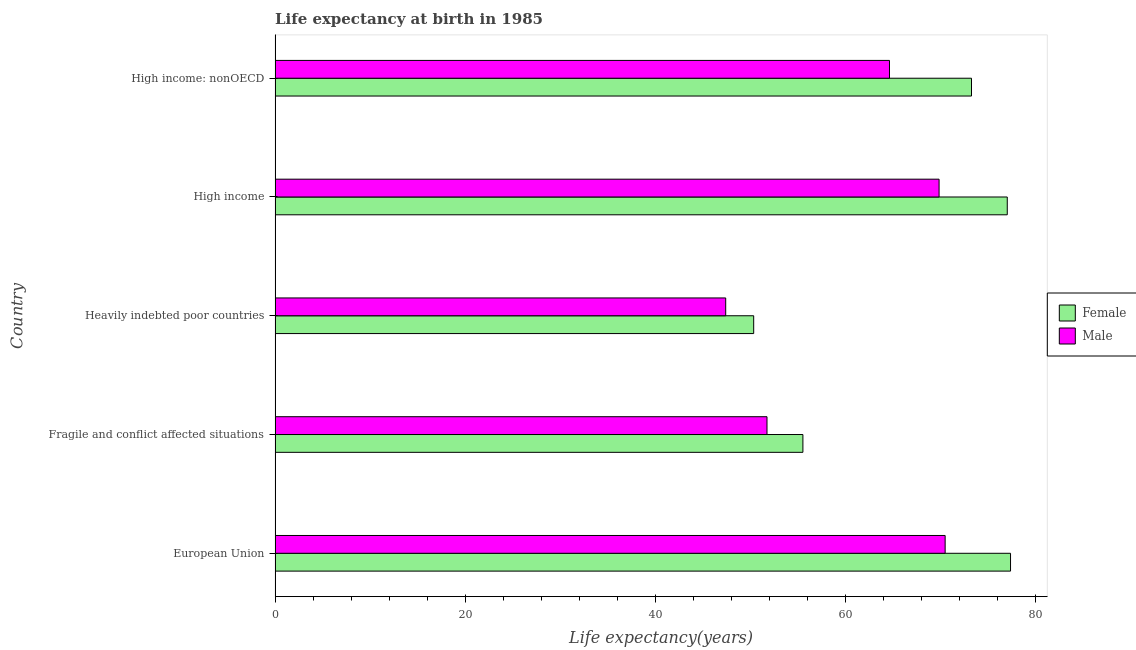How many different coloured bars are there?
Offer a terse response. 2. How many groups of bars are there?
Provide a short and direct response. 5. What is the label of the 5th group of bars from the top?
Give a very brief answer. European Union. In how many cases, is the number of bars for a given country not equal to the number of legend labels?
Make the answer very short. 0. What is the life expectancy(male) in High income?
Make the answer very short. 69.88. Across all countries, what is the maximum life expectancy(male)?
Make the answer very short. 70.52. Across all countries, what is the minimum life expectancy(female)?
Provide a succinct answer. 50.37. In which country was the life expectancy(female) maximum?
Your answer should be very brief. European Union. In which country was the life expectancy(male) minimum?
Provide a short and direct response. Heavily indebted poor countries. What is the total life expectancy(female) in the graph?
Offer a very short reply. 333.68. What is the difference between the life expectancy(female) in European Union and that in High income?
Your answer should be very brief. 0.34. What is the difference between the life expectancy(male) in Heavily indebted poor countries and the life expectancy(female) in Fragile and conflict affected situations?
Your answer should be very brief. -8.13. What is the average life expectancy(male) per country?
Offer a terse response. 60.85. What is the difference between the life expectancy(female) and life expectancy(male) in Heavily indebted poor countries?
Your answer should be very brief. 2.95. In how many countries, is the life expectancy(male) greater than 60 years?
Your answer should be compact. 3. What is the ratio of the life expectancy(male) in European Union to that in High income: nonOECD?
Keep it short and to the point. 1.09. Is the life expectancy(female) in Heavily indebted poor countries less than that in High income: nonOECD?
Your answer should be very brief. Yes. Is the difference between the life expectancy(female) in Fragile and conflict affected situations and High income greater than the difference between the life expectancy(male) in Fragile and conflict affected situations and High income?
Your answer should be compact. No. What is the difference between the highest and the second highest life expectancy(male)?
Make the answer very short. 0.64. What is the difference between the highest and the lowest life expectancy(male)?
Make the answer very short. 23.09. In how many countries, is the life expectancy(male) greater than the average life expectancy(male) taken over all countries?
Offer a very short reply. 3. Is the sum of the life expectancy(female) in Fragile and conflict affected situations and High income greater than the maximum life expectancy(male) across all countries?
Offer a terse response. Yes. What does the 2nd bar from the top in Fragile and conflict affected situations represents?
Make the answer very short. Female. What does the 1st bar from the bottom in High income represents?
Provide a succinct answer. Female. How many bars are there?
Your response must be concise. 10. What is the difference between two consecutive major ticks on the X-axis?
Provide a short and direct response. 20. Are the values on the major ticks of X-axis written in scientific E-notation?
Your answer should be compact. No. Does the graph contain grids?
Ensure brevity in your answer.  No. What is the title of the graph?
Provide a short and direct response. Life expectancy at birth in 1985. What is the label or title of the X-axis?
Offer a very short reply. Life expectancy(years). What is the label or title of the Y-axis?
Your answer should be compact. Country. What is the Life expectancy(years) in Female in European Union?
Give a very brief answer. 77.4. What is the Life expectancy(years) in Male in European Union?
Provide a short and direct response. 70.52. What is the Life expectancy(years) in Female in Fragile and conflict affected situations?
Provide a short and direct response. 55.55. What is the Life expectancy(years) of Male in Fragile and conflict affected situations?
Your answer should be very brief. 51.77. What is the Life expectancy(years) of Female in Heavily indebted poor countries?
Provide a short and direct response. 50.37. What is the Life expectancy(years) in Male in Heavily indebted poor countries?
Your response must be concise. 47.43. What is the Life expectancy(years) in Female in High income?
Provide a short and direct response. 77.06. What is the Life expectancy(years) of Male in High income?
Make the answer very short. 69.88. What is the Life expectancy(years) of Female in High income: nonOECD?
Offer a terse response. 73.29. What is the Life expectancy(years) in Male in High income: nonOECD?
Offer a terse response. 64.66. Across all countries, what is the maximum Life expectancy(years) of Female?
Give a very brief answer. 77.4. Across all countries, what is the maximum Life expectancy(years) in Male?
Your answer should be compact. 70.52. Across all countries, what is the minimum Life expectancy(years) in Female?
Offer a very short reply. 50.37. Across all countries, what is the minimum Life expectancy(years) in Male?
Ensure brevity in your answer.  47.43. What is the total Life expectancy(years) in Female in the graph?
Your answer should be compact. 333.68. What is the total Life expectancy(years) in Male in the graph?
Your answer should be very brief. 304.27. What is the difference between the Life expectancy(years) of Female in European Union and that in Fragile and conflict affected situations?
Your answer should be compact. 21.85. What is the difference between the Life expectancy(years) of Male in European Union and that in Fragile and conflict affected situations?
Ensure brevity in your answer.  18.75. What is the difference between the Life expectancy(years) in Female in European Union and that in Heavily indebted poor countries?
Give a very brief answer. 27.03. What is the difference between the Life expectancy(years) in Male in European Union and that in Heavily indebted poor countries?
Keep it short and to the point. 23.09. What is the difference between the Life expectancy(years) in Female in European Union and that in High income?
Offer a terse response. 0.34. What is the difference between the Life expectancy(years) of Male in European Union and that in High income?
Keep it short and to the point. 0.64. What is the difference between the Life expectancy(years) of Female in European Union and that in High income: nonOECD?
Keep it short and to the point. 4.11. What is the difference between the Life expectancy(years) of Male in European Union and that in High income: nonOECD?
Make the answer very short. 5.86. What is the difference between the Life expectancy(years) of Female in Fragile and conflict affected situations and that in Heavily indebted poor countries?
Ensure brevity in your answer.  5.18. What is the difference between the Life expectancy(years) of Male in Fragile and conflict affected situations and that in Heavily indebted poor countries?
Make the answer very short. 4.35. What is the difference between the Life expectancy(years) of Female in Fragile and conflict affected situations and that in High income?
Offer a terse response. -21.51. What is the difference between the Life expectancy(years) of Male in Fragile and conflict affected situations and that in High income?
Your answer should be very brief. -18.11. What is the difference between the Life expectancy(years) in Female in Fragile and conflict affected situations and that in High income: nonOECD?
Your response must be concise. -17.74. What is the difference between the Life expectancy(years) of Male in Fragile and conflict affected situations and that in High income: nonOECD?
Keep it short and to the point. -12.89. What is the difference between the Life expectancy(years) in Female in Heavily indebted poor countries and that in High income?
Your answer should be compact. -26.69. What is the difference between the Life expectancy(years) in Male in Heavily indebted poor countries and that in High income?
Your response must be concise. -22.46. What is the difference between the Life expectancy(years) in Female in Heavily indebted poor countries and that in High income: nonOECD?
Ensure brevity in your answer.  -22.92. What is the difference between the Life expectancy(years) in Male in Heavily indebted poor countries and that in High income: nonOECD?
Your answer should be very brief. -17.24. What is the difference between the Life expectancy(years) in Female in High income and that in High income: nonOECD?
Offer a terse response. 3.77. What is the difference between the Life expectancy(years) of Male in High income and that in High income: nonOECD?
Make the answer very short. 5.22. What is the difference between the Life expectancy(years) in Female in European Union and the Life expectancy(years) in Male in Fragile and conflict affected situations?
Give a very brief answer. 25.63. What is the difference between the Life expectancy(years) of Female in European Union and the Life expectancy(years) of Male in Heavily indebted poor countries?
Your response must be concise. 29.98. What is the difference between the Life expectancy(years) in Female in European Union and the Life expectancy(years) in Male in High income?
Offer a very short reply. 7.52. What is the difference between the Life expectancy(years) in Female in European Union and the Life expectancy(years) in Male in High income: nonOECD?
Offer a terse response. 12.74. What is the difference between the Life expectancy(years) of Female in Fragile and conflict affected situations and the Life expectancy(years) of Male in Heavily indebted poor countries?
Offer a very short reply. 8.13. What is the difference between the Life expectancy(years) of Female in Fragile and conflict affected situations and the Life expectancy(years) of Male in High income?
Provide a succinct answer. -14.33. What is the difference between the Life expectancy(years) in Female in Fragile and conflict affected situations and the Life expectancy(years) in Male in High income: nonOECD?
Offer a terse response. -9.11. What is the difference between the Life expectancy(years) of Female in Heavily indebted poor countries and the Life expectancy(years) of Male in High income?
Your answer should be very brief. -19.51. What is the difference between the Life expectancy(years) in Female in Heavily indebted poor countries and the Life expectancy(years) in Male in High income: nonOECD?
Provide a succinct answer. -14.29. What is the difference between the Life expectancy(years) of Female in High income and the Life expectancy(years) of Male in High income: nonOECD?
Your answer should be very brief. 12.4. What is the average Life expectancy(years) in Female per country?
Keep it short and to the point. 66.74. What is the average Life expectancy(years) of Male per country?
Keep it short and to the point. 60.85. What is the difference between the Life expectancy(years) in Female and Life expectancy(years) in Male in European Union?
Your response must be concise. 6.88. What is the difference between the Life expectancy(years) of Female and Life expectancy(years) of Male in Fragile and conflict affected situations?
Provide a short and direct response. 3.78. What is the difference between the Life expectancy(years) in Female and Life expectancy(years) in Male in Heavily indebted poor countries?
Provide a short and direct response. 2.95. What is the difference between the Life expectancy(years) in Female and Life expectancy(years) in Male in High income?
Make the answer very short. 7.18. What is the difference between the Life expectancy(years) of Female and Life expectancy(years) of Male in High income: nonOECD?
Your answer should be very brief. 8.63. What is the ratio of the Life expectancy(years) in Female in European Union to that in Fragile and conflict affected situations?
Offer a very short reply. 1.39. What is the ratio of the Life expectancy(years) in Male in European Union to that in Fragile and conflict affected situations?
Your response must be concise. 1.36. What is the ratio of the Life expectancy(years) of Female in European Union to that in Heavily indebted poor countries?
Give a very brief answer. 1.54. What is the ratio of the Life expectancy(years) of Male in European Union to that in Heavily indebted poor countries?
Your answer should be very brief. 1.49. What is the ratio of the Life expectancy(years) in Male in European Union to that in High income?
Offer a terse response. 1.01. What is the ratio of the Life expectancy(years) in Female in European Union to that in High income: nonOECD?
Give a very brief answer. 1.06. What is the ratio of the Life expectancy(years) of Male in European Union to that in High income: nonOECD?
Offer a very short reply. 1.09. What is the ratio of the Life expectancy(years) in Female in Fragile and conflict affected situations to that in Heavily indebted poor countries?
Make the answer very short. 1.1. What is the ratio of the Life expectancy(years) in Male in Fragile and conflict affected situations to that in Heavily indebted poor countries?
Offer a very short reply. 1.09. What is the ratio of the Life expectancy(years) in Female in Fragile and conflict affected situations to that in High income?
Your answer should be compact. 0.72. What is the ratio of the Life expectancy(years) in Male in Fragile and conflict affected situations to that in High income?
Give a very brief answer. 0.74. What is the ratio of the Life expectancy(years) of Female in Fragile and conflict affected situations to that in High income: nonOECD?
Offer a very short reply. 0.76. What is the ratio of the Life expectancy(years) of Male in Fragile and conflict affected situations to that in High income: nonOECD?
Your response must be concise. 0.8. What is the ratio of the Life expectancy(years) of Female in Heavily indebted poor countries to that in High income?
Your answer should be very brief. 0.65. What is the ratio of the Life expectancy(years) of Male in Heavily indebted poor countries to that in High income?
Offer a very short reply. 0.68. What is the ratio of the Life expectancy(years) in Female in Heavily indebted poor countries to that in High income: nonOECD?
Offer a very short reply. 0.69. What is the ratio of the Life expectancy(years) in Male in Heavily indebted poor countries to that in High income: nonOECD?
Your response must be concise. 0.73. What is the ratio of the Life expectancy(years) in Female in High income to that in High income: nonOECD?
Your answer should be very brief. 1.05. What is the ratio of the Life expectancy(years) of Male in High income to that in High income: nonOECD?
Your answer should be compact. 1.08. What is the difference between the highest and the second highest Life expectancy(years) in Female?
Provide a succinct answer. 0.34. What is the difference between the highest and the second highest Life expectancy(years) in Male?
Offer a very short reply. 0.64. What is the difference between the highest and the lowest Life expectancy(years) of Female?
Your answer should be very brief. 27.03. What is the difference between the highest and the lowest Life expectancy(years) of Male?
Offer a terse response. 23.09. 